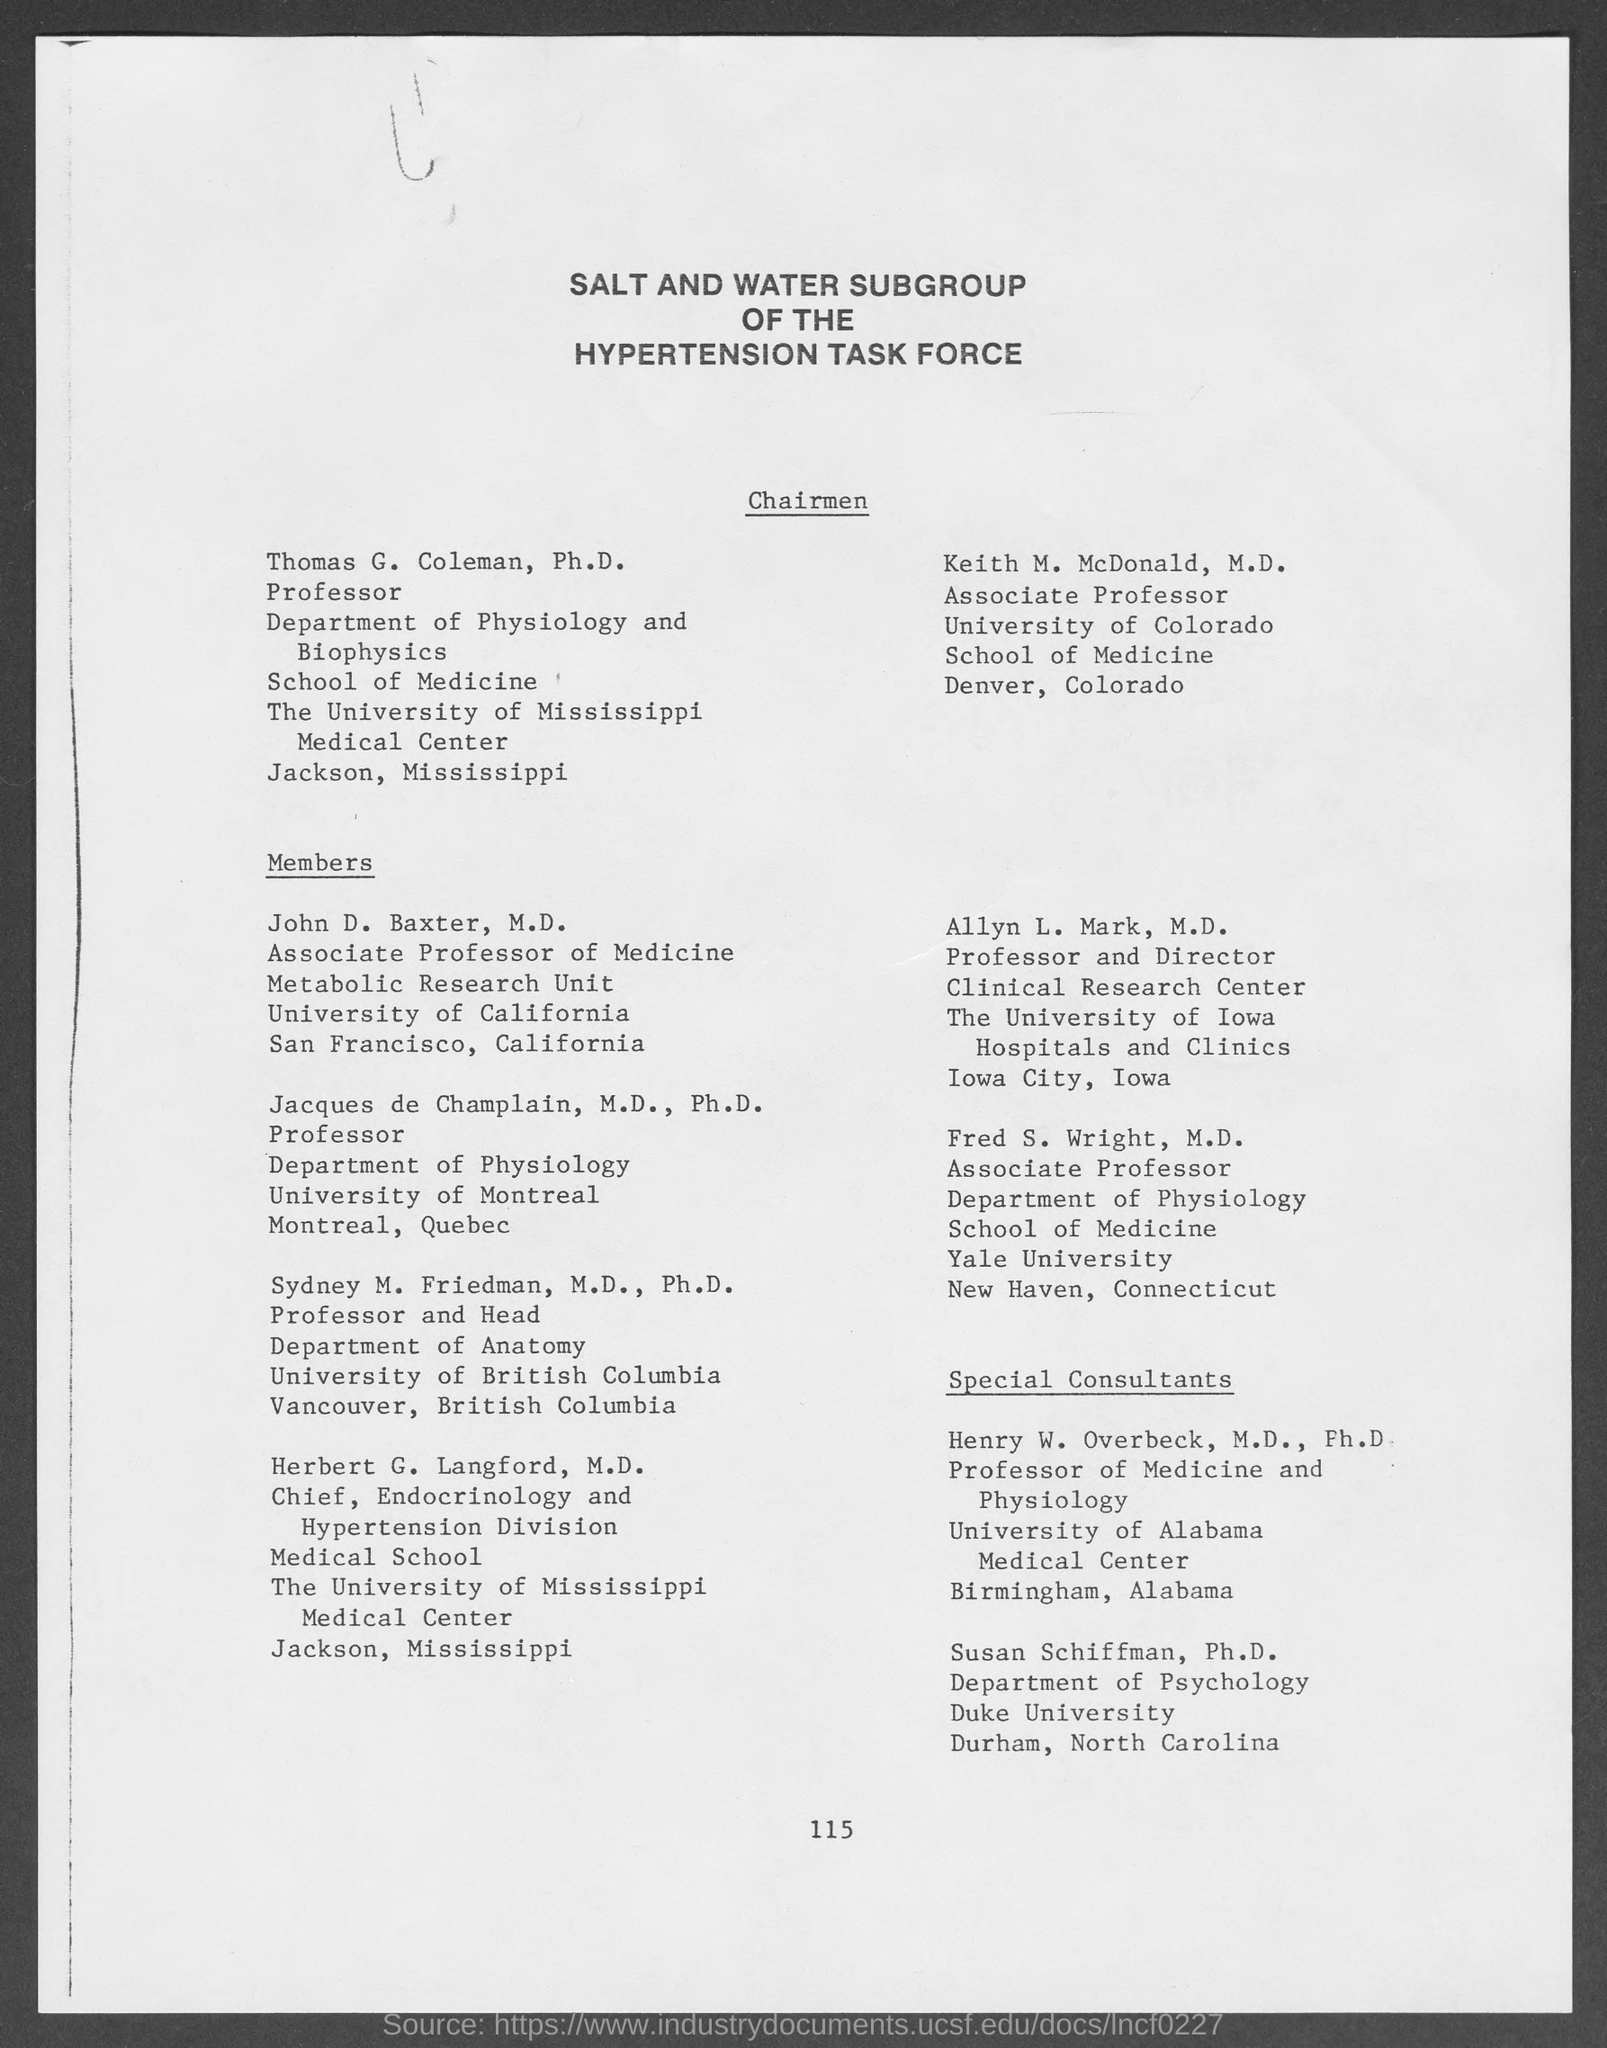Who is the Professor and Director, Clinical Research Center?
Offer a very short reply. Allyn L. Mark, M.D. Who is the Chief of Endocrinology and Hypertension Division?
Make the answer very short. Herbert G. Langford, M.D. 